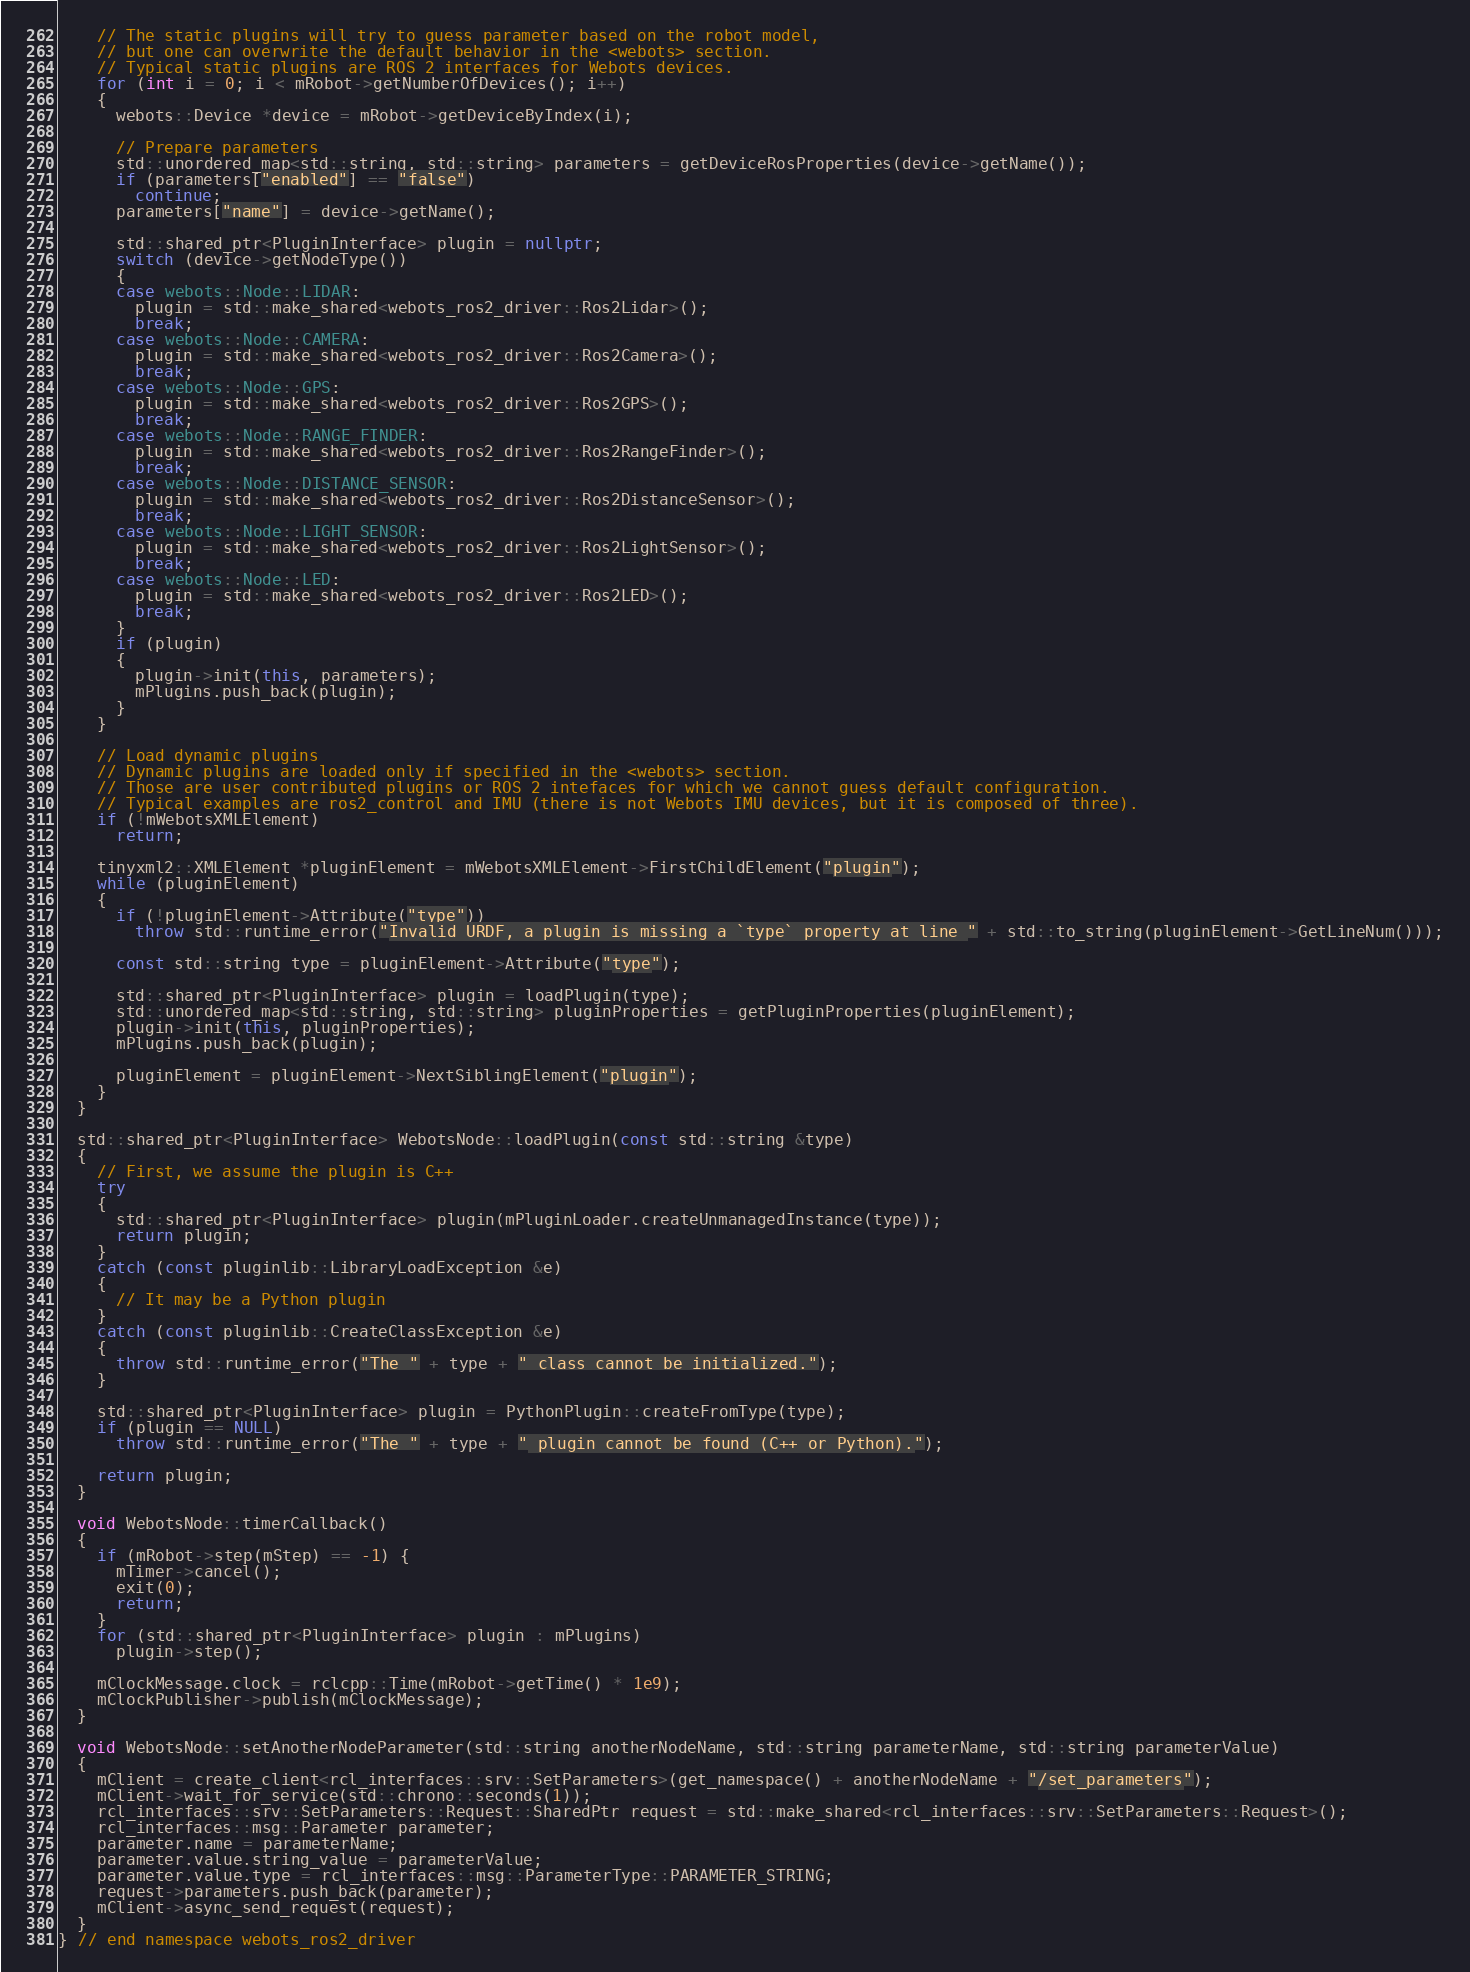Convert code to text. <code><loc_0><loc_0><loc_500><loc_500><_C++_>    // The static plugins will try to guess parameter based on the robot model,
    // but one can overwrite the default behavior in the <webots> section.
    // Typical static plugins are ROS 2 interfaces for Webots devices.
    for (int i = 0; i < mRobot->getNumberOfDevices(); i++)
    {
      webots::Device *device = mRobot->getDeviceByIndex(i);

      // Prepare parameters
      std::unordered_map<std::string, std::string> parameters = getDeviceRosProperties(device->getName());
      if (parameters["enabled"] == "false")
        continue;
      parameters["name"] = device->getName();

      std::shared_ptr<PluginInterface> plugin = nullptr;
      switch (device->getNodeType())
      {
      case webots::Node::LIDAR:
        plugin = std::make_shared<webots_ros2_driver::Ros2Lidar>();
        break;
      case webots::Node::CAMERA:
        plugin = std::make_shared<webots_ros2_driver::Ros2Camera>();
        break;
      case webots::Node::GPS:
        plugin = std::make_shared<webots_ros2_driver::Ros2GPS>();
        break;
      case webots::Node::RANGE_FINDER:
        plugin = std::make_shared<webots_ros2_driver::Ros2RangeFinder>();
        break;
      case webots::Node::DISTANCE_SENSOR:
        plugin = std::make_shared<webots_ros2_driver::Ros2DistanceSensor>();
        break;
      case webots::Node::LIGHT_SENSOR:
        plugin = std::make_shared<webots_ros2_driver::Ros2LightSensor>();
        break;
      case webots::Node::LED:
        plugin = std::make_shared<webots_ros2_driver::Ros2LED>();
        break;
      }
      if (plugin)
      {
        plugin->init(this, parameters);
        mPlugins.push_back(plugin);
      }
    }

    // Load dynamic plugins
    // Dynamic plugins are loaded only if specified in the <webots> section.
    // Those are user contributed plugins or ROS 2 intefaces for which we cannot guess default configuration.
    // Typical examples are ros2_control and IMU (there is not Webots IMU devices, but it is composed of three).
    if (!mWebotsXMLElement)
      return;

    tinyxml2::XMLElement *pluginElement = mWebotsXMLElement->FirstChildElement("plugin");
    while (pluginElement)
    {
      if (!pluginElement->Attribute("type"))
        throw std::runtime_error("Invalid URDF, a plugin is missing a `type` property at line " + std::to_string(pluginElement->GetLineNum()));

      const std::string type = pluginElement->Attribute("type");

      std::shared_ptr<PluginInterface> plugin = loadPlugin(type);
      std::unordered_map<std::string, std::string> pluginProperties = getPluginProperties(pluginElement);
      plugin->init(this, pluginProperties);
      mPlugins.push_back(plugin);

      pluginElement = pluginElement->NextSiblingElement("plugin");
    }
  }

  std::shared_ptr<PluginInterface> WebotsNode::loadPlugin(const std::string &type)
  {
    // First, we assume the plugin is C++
    try
    {
      std::shared_ptr<PluginInterface> plugin(mPluginLoader.createUnmanagedInstance(type));
      return plugin;
    }
    catch (const pluginlib::LibraryLoadException &e)
    {
      // It may be a Python plugin
    }
    catch (const pluginlib::CreateClassException &e)
    {
      throw std::runtime_error("The " + type + " class cannot be initialized.");
    }

    std::shared_ptr<PluginInterface> plugin = PythonPlugin::createFromType(type);
    if (plugin == NULL)
      throw std::runtime_error("The " + type + " plugin cannot be found (C++ or Python).");

    return plugin;
  }

  void WebotsNode::timerCallback()
  {
    if (mRobot->step(mStep) == -1) {
      mTimer->cancel();
      exit(0);
      return;
    }
    for (std::shared_ptr<PluginInterface> plugin : mPlugins)
      plugin->step();

    mClockMessage.clock = rclcpp::Time(mRobot->getTime() * 1e9);
    mClockPublisher->publish(mClockMessage);
  }

  void WebotsNode::setAnotherNodeParameter(std::string anotherNodeName, std::string parameterName, std::string parameterValue)
  {
    mClient = create_client<rcl_interfaces::srv::SetParameters>(get_namespace() + anotherNodeName + "/set_parameters");
    mClient->wait_for_service(std::chrono::seconds(1));
    rcl_interfaces::srv::SetParameters::Request::SharedPtr request = std::make_shared<rcl_interfaces::srv::SetParameters::Request>();
    rcl_interfaces::msg::Parameter parameter;
    parameter.name = parameterName;
    parameter.value.string_value = parameterValue;
    parameter.value.type = rcl_interfaces::msg::ParameterType::PARAMETER_STRING;
    request->parameters.push_back(parameter);
    mClient->async_send_request(request);
  }
} // end namespace webots_ros2_driver
</code> 